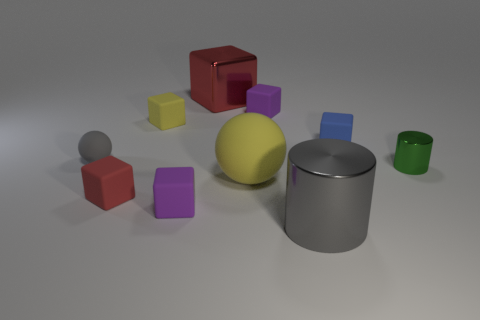Subtract 3 blocks. How many blocks are left? 3 Subtract all blue blocks. How many blocks are left? 5 Subtract all yellow cubes. How many cubes are left? 5 Subtract all red blocks. Subtract all cyan spheres. How many blocks are left? 4 Subtract all spheres. How many objects are left? 8 Subtract all gray blocks. Subtract all large gray cylinders. How many objects are left? 9 Add 7 large yellow rubber things. How many large yellow rubber things are left? 8 Add 5 tiny gray spheres. How many tiny gray spheres exist? 6 Subtract 0 brown spheres. How many objects are left? 10 